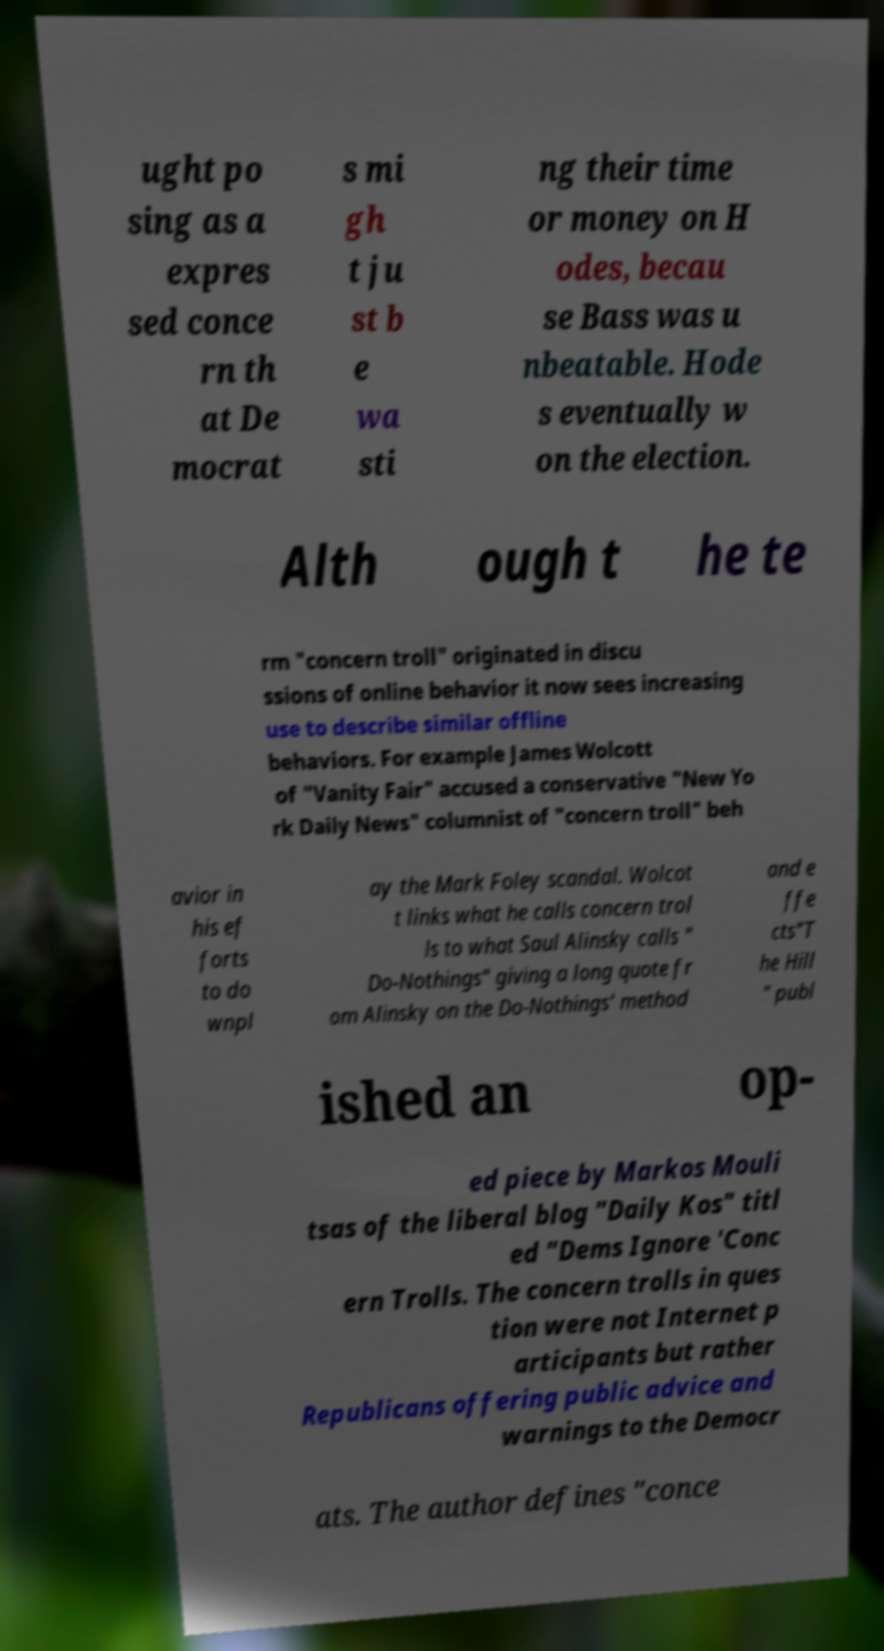Can you accurately transcribe the text from the provided image for me? ught po sing as a expres sed conce rn th at De mocrat s mi gh t ju st b e wa sti ng their time or money on H odes, becau se Bass was u nbeatable. Hode s eventually w on the election. Alth ough t he te rm "concern troll" originated in discu ssions of online behavior it now sees increasing use to describe similar offline behaviors. For example James Wolcott of "Vanity Fair" accused a conservative "New Yo rk Daily News" columnist of "concern troll" beh avior in his ef forts to do wnpl ay the Mark Foley scandal. Wolcot t links what he calls concern trol ls to what Saul Alinsky calls " Do-Nothings" giving a long quote fr om Alinsky on the Do-Nothings' method and e ffe cts"T he Hill " publ ished an op- ed piece by Markos Mouli tsas of the liberal blog "Daily Kos" titl ed "Dems Ignore 'Conc ern Trolls. The concern trolls in ques tion were not Internet p articipants but rather Republicans offering public advice and warnings to the Democr ats. The author defines "conce 